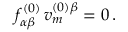Convert formula to latex. <formula><loc_0><loc_0><loc_500><loc_500>f _ { \alpha \beta } ^ { ( 0 ) } \, v _ { m } ^ { ( 0 ) \beta } = 0 \, .</formula> 